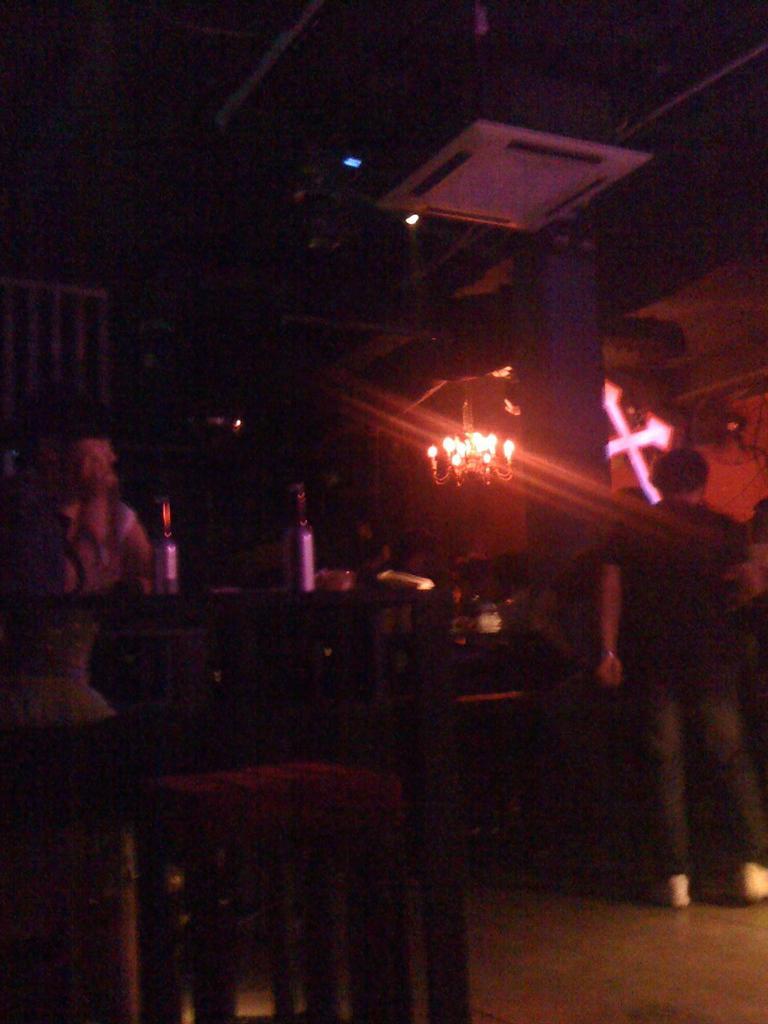Could you give a brief overview of what you see in this image? In this picture I can see group of people, there are bottles, chairs, there is a holy cross, there is a chandelier and a cassette air conditioner. 